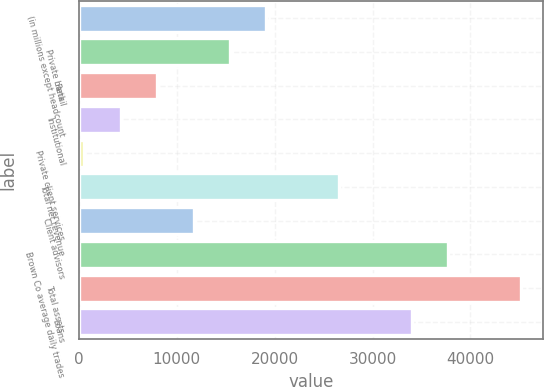Convert chart. <chart><loc_0><loc_0><loc_500><loc_500><bar_chart><fcel>(in millions except headcount<fcel>Private bank<fcel>Retail<fcel>Institutional<fcel>Private client services<fcel>Total net revenue<fcel>Client advisors<fcel>Brown Co average daily trades<fcel>Total assets<fcel>Loans<nl><fcel>19150.5<fcel>15430.4<fcel>7990.2<fcel>4270.1<fcel>550<fcel>26590.7<fcel>11710.3<fcel>37751<fcel>45191.2<fcel>34030.9<nl></chart> 